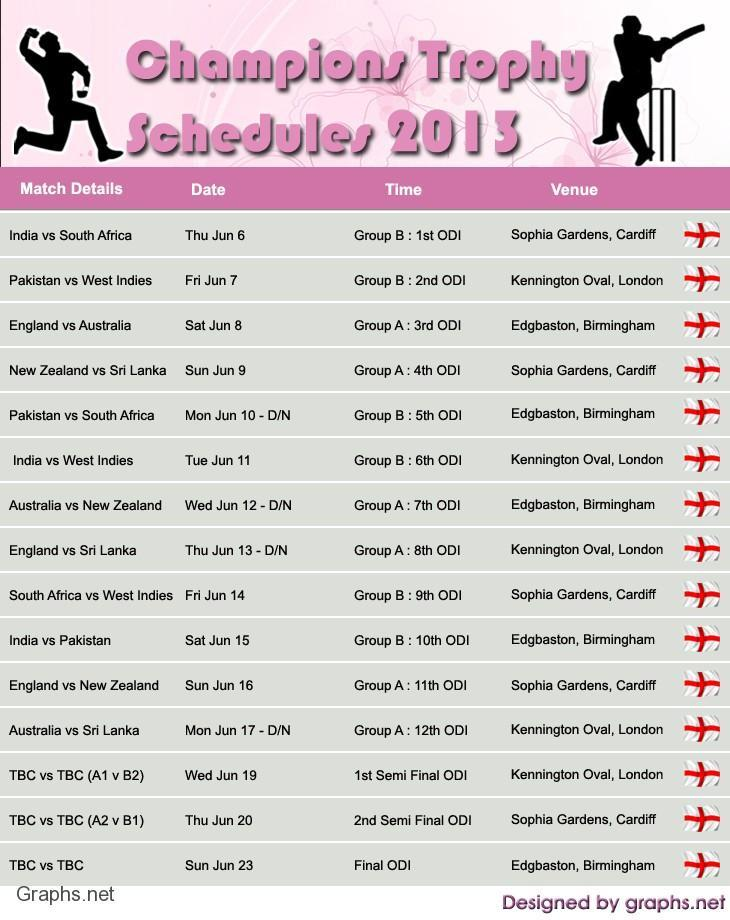How many matches have venue Kennington Oval, London?
Answer the question with a short phrase. 5 How many matches scheduled on Friday? 2 How many matches scheduled on Saturday? 2 